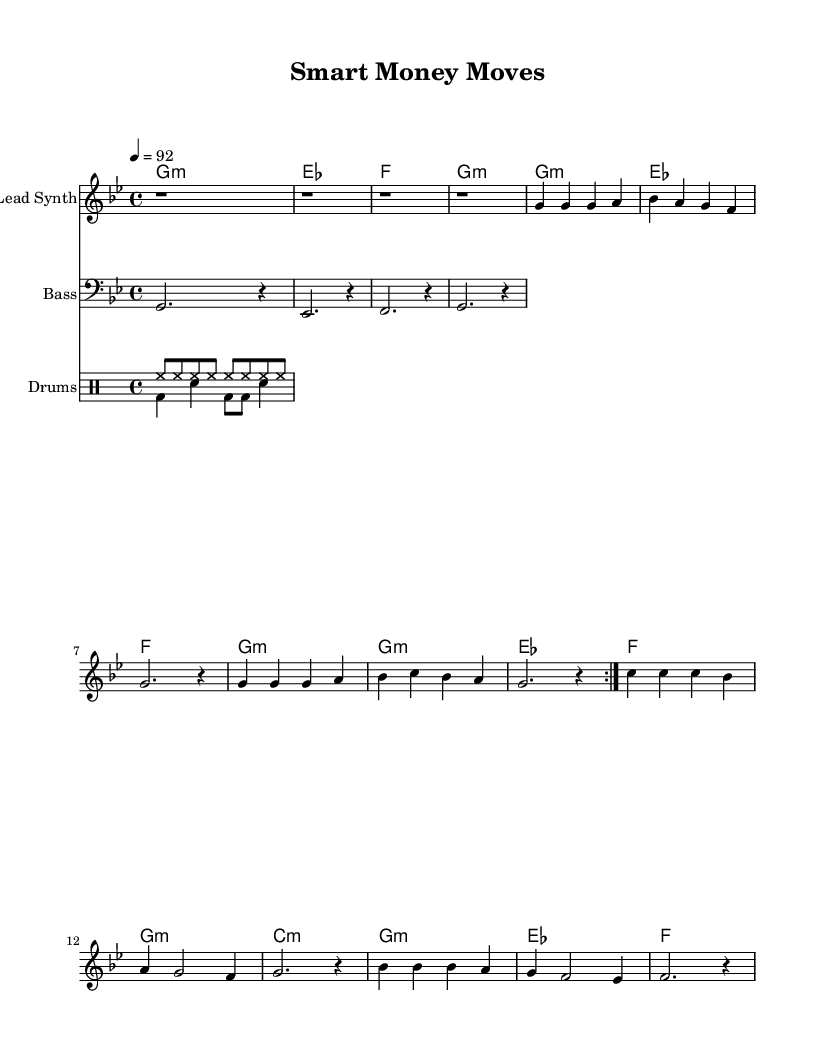What is the key signature of this music? The key signature is G minor, which has two flats. You can identify the key by looking at the beginning of the sheet music where the key signature is indicated.
Answer: G minor What is the time signature of this music? The time signature is 4/4, which consists of four beats per measure. This can be determined from the notation near the start of the sheet music, which clearly shows the fraction.
Answer: 4/4 What is the tempo of this piece? The tempo is indicated as 92 beats per minute. This information is found in the tempo marking at the beginning of the score, where it shows the beats per minute as a numerical value.
Answer: 92 How many volta sections are there in the lead synth part? There are 2 volta sections in the lead synth part as indicated by the \repeat volta 2 command, which specifies that the section should be repeated twice.
Answer: 2 What is the chord progression pattern in the lead synth part? The chord progression follows a pattern of G minor, E flat major, F major, G minor. By analyzing the chord names associated with the lead synth, you can see this repeated structure.
Answer: G minor, E flat major, F major, G minor How is the rhythmic pattern structured in the drum part? The rhythmic structure combines a steady hi-hat pattern with a downbeat kick and snare arrangement. The hihat plays continuously, while the bass drum and snare add variation, creating a typical hip-hop groove.
Answer: Hi-hat and kick-snare pattern What mood or theme does this music reflect based on its elements? The music reflects a theme of financial success and wealth building, as suggested by the title "Smart Money Moves" and the harmonic and rhythmic choices which typically accompany themes of aspiration in hip-hop.
Answer: Financial success 